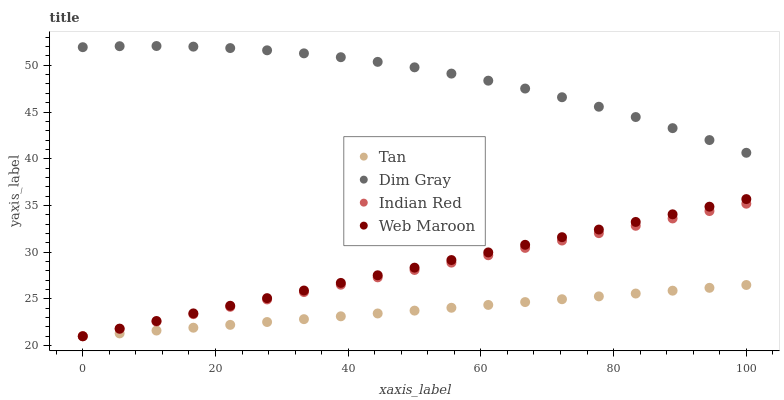Does Tan have the minimum area under the curve?
Answer yes or no. Yes. Does Dim Gray have the maximum area under the curve?
Answer yes or no. Yes. Does Web Maroon have the minimum area under the curve?
Answer yes or no. No. Does Web Maroon have the maximum area under the curve?
Answer yes or no. No. Is Indian Red the smoothest?
Answer yes or no. Yes. Is Dim Gray the roughest?
Answer yes or no. Yes. Is Web Maroon the smoothest?
Answer yes or no. No. Is Web Maroon the roughest?
Answer yes or no. No. Does Tan have the lowest value?
Answer yes or no. Yes. Does Dim Gray have the lowest value?
Answer yes or no. No. Does Dim Gray have the highest value?
Answer yes or no. Yes. Does Web Maroon have the highest value?
Answer yes or no. No. Is Web Maroon less than Dim Gray?
Answer yes or no. Yes. Is Dim Gray greater than Indian Red?
Answer yes or no. Yes. Does Tan intersect Indian Red?
Answer yes or no. Yes. Is Tan less than Indian Red?
Answer yes or no. No. Is Tan greater than Indian Red?
Answer yes or no. No. Does Web Maroon intersect Dim Gray?
Answer yes or no. No. 